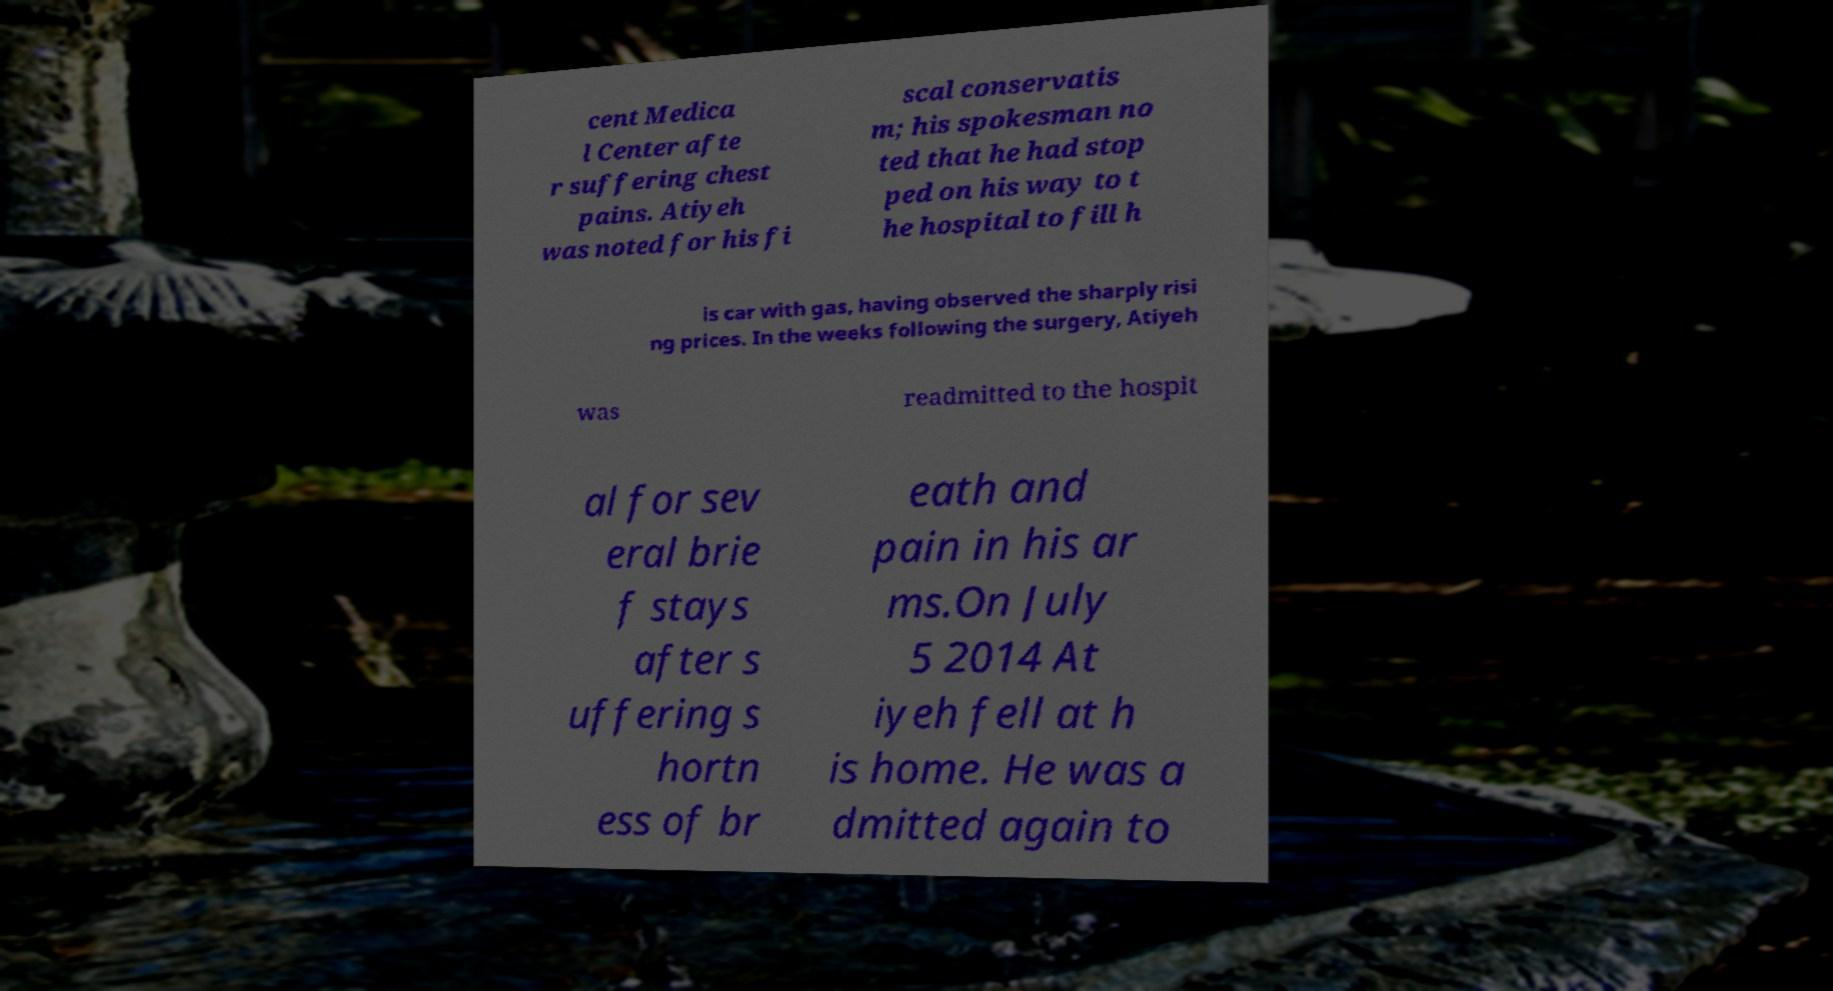For documentation purposes, I need the text within this image transcribed. Could you provide that? cent Medica l Center afte r suffering chest pains. Atiyeh was noted for his fi scal conservatis m; his spokesman no ted that he had stop ped on his way to t he hospital to fill h is car with gas, having observed the sharply risi ng prices. In the weeks following the surgery, Atiyeh was readmitted to the hospit al for sev eral brie f stays after s uffering s hortn ess of br eath and pain in his ar ms.On July 5 2014 At iyeh fell at h is home. He was a dmitted again to 